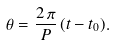<formula> <loc_0><loc_0><loc_500><loc_500>\theta = \frac { 2 \, \pi } { P } \, ( t - t _ { 0 } ) .</formula> 